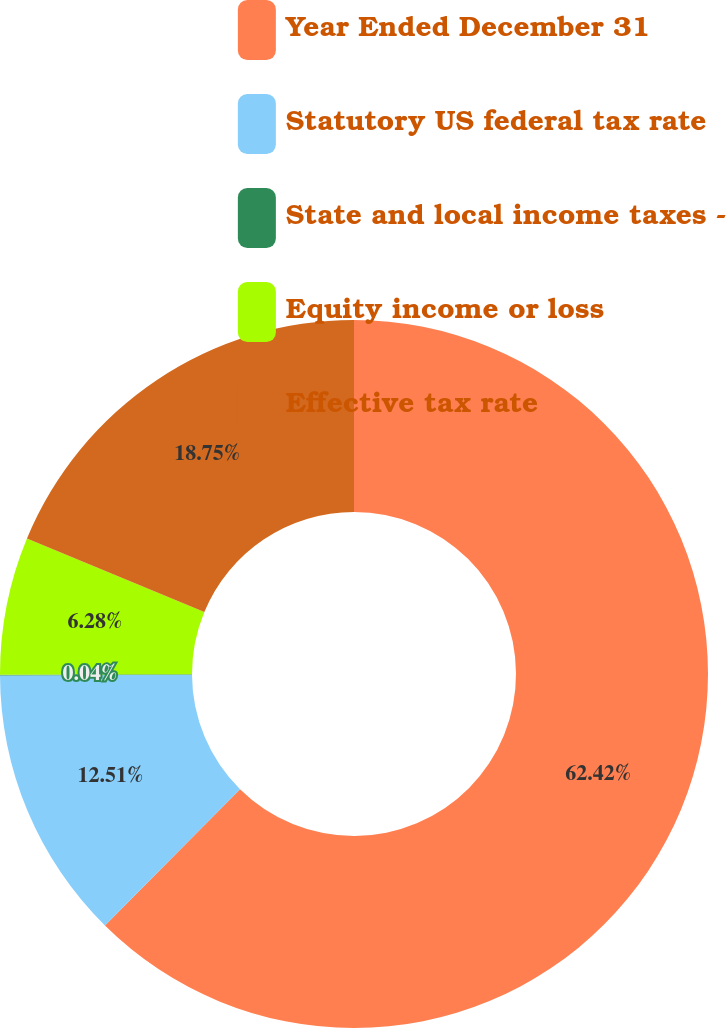Convert chart. <chart><loc_0><loc_0><loc_500><loc_500><pie_chart><fcel>Year Ended December 31<fcel>Statutory US federal tax rate<fcel>State and local income taxes -<fcel>Equity income or loss<fcel>Effective tax rate<nl><fcel>62.42%<fcel>12.51%<fcel>0.04%<fcel>6.28%<fcel>18.75%<nl></chart> 